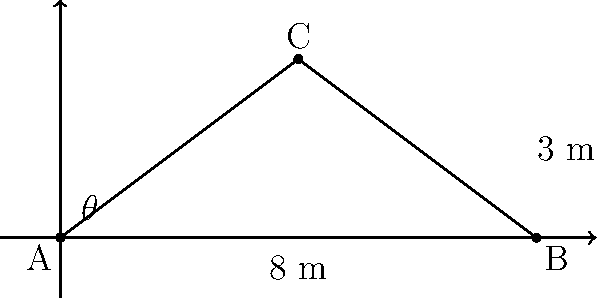In a traditional Paraguayan house with a thatched roof, the base of the roof is 8 meters wide, and the peak of the roof is 3 meters above the base. What is the angle $\theta$ between the roof and the horizontal base, rounded to the nearest degree? To find the angle $\theta$, we need to use the tangent function from trigonometry. Let's approach this step-by-step:

1) In the right triangle formed by half of the roof, we know:
   - The opposite side (height) is 3 meters
   - Half of the base is 4 meters (since the total base is 8 meters)

2) The tangent of an angle is defined as the ratio of the opposite side to the adjacent side:

   $\tan(\theta) = \frac{\text{opposite}}{\text{adjacent}} = \frac{\text{height}}{\text{half base}}$

3) Substituting our known values:

   $\tan(\theta) = \frac{3}{4}$

4) To find $\theta$, we need to use the inverse tangent function (arctan or $\tan^{-1}$):

   $\theta = \tan^{-1}(\frac{3}{4})$

5) Using a calculator or trigonometric tables:

   $\theta \approx 36.87°$

6) Rounding to the nearest degree:

   $\theta \approx 37°$

Therefore, the angle between the roof and the horizontal base is approximately 37 degrees.
Answer: $37°$ 